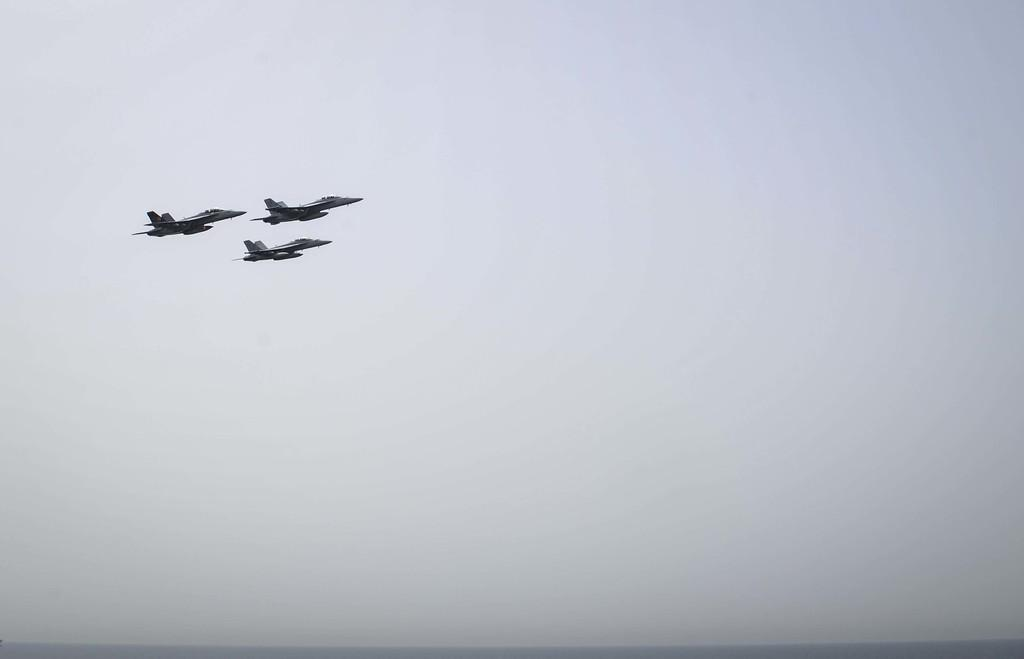How many planes can be seen in the image? There are three planes in the image. What are the planes doing in the image? The planes are flying in the sky. Who is the manager of the planes in the image? There is no information about a manager or any human involvement in the image; it simply shows three planes flying in the sky. 